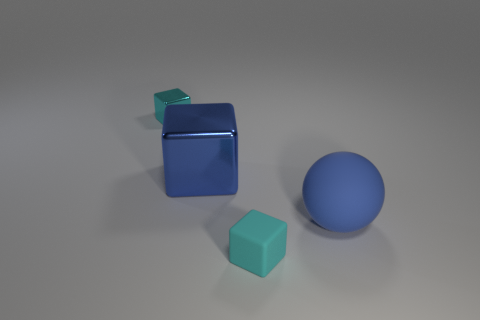Is the number of cyan metallic blocks less than the number of small gray matte blocks?
Offer a terse response. No. What is the material of the thing that is both to the left of the large sphere and right of the blue metal cube?
Keep it short and to the point. Rubber. There is a cyan object on the left side of the cyan block right of the cyan object that is behind the blue sphere; what size is it?
Your answer should be very brief. Small. Does the blue rubber object have the same shape as the cyan thing that is behind the big blue block?
Make the answer very short. No. How many tiny things are behind the large blue sphere and in front of the blue matte object?
Give a very brief answer. 0. What number of gray objects are either small things or tiny metallic blocks?
Offer a terse response. 0. There is a small thing behind the sphere; is its color the same as the tiny block that is in front of the blue matte ball?
Your answer should be compact. Yes. What is the color of the tiny object that is in front of the small cube behind the rubber thing in front of the matte ball?
Your answer should be very brief. Cyan. There is a tiny block that is in front of the large blue shiny thing; are there any cyan matte blocks right of it?
Provide a short and direct response. No. There is a big blue object on the right side of the large metallic cube; is it the same shape as the small cyan rubber object?
Give a very brief answer. No. 